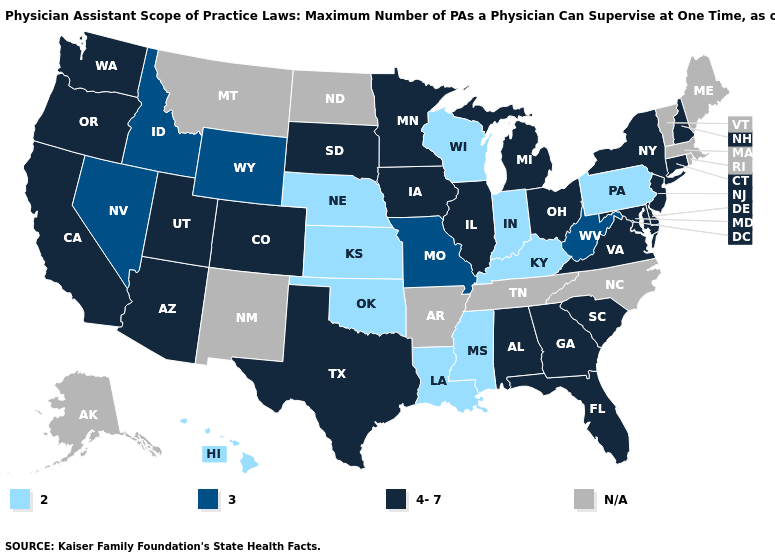Name the states that have a value in the range N/A?
Be succinct. Alaska, Arkansas, Maine, Massachusetts, Montana, New Mexico, North Carolina, North Dakota, Rhode Island, Tennessee, Vermont. What is the lowest value in the USA?
Short answer required. 2. Which states have the highest value in the USA?
Short answer required. Alabama, Arizona, California, Colorado, Connecticut, Delaware, Florida, Georgia, Illinois, Iowa, Maryland, Michigan, Minnesota, New Hampshire, New Jersey, New York, Ohio, Oregon, South Carolina, South Dakota, Texas, Utah, Virginia, Washington. What is the lowest value in states that border Indiana?
Answer briefly. 2. What is the value of Maine?
Be succinct. N/A. What is the value of Hawaii?
Give a very brief answer. 2. What is the lowest value in the MidWest?
Be succinct. 2. What is the value of Alabama?
Short answer required. 4-7. What is the value of Connecticut?
Short answer required. 4-7. What is the lowest value in the USA?
Write a very short answer. 2. What is the lowest value in the Northeast?
Concise answer only. 2. What is the lowest value in states that border North Dakota?
Short answer required. 4-7. Which states have the lowest value in the West?
Be succinct. Hawaii. How many symbols are there in the legend?
Concise answer only. 4. 